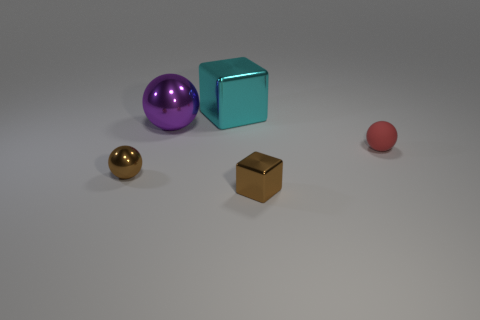Add 1 tiny brown metallic things. How many objects exist? 6 Subtract all red matte spheres. How many spheres are left? 2 Subtract all spheres. How many objects are left? 2 Add 3 small cylinders. How many small cylinders exist? 3 Subtract all brown balls. How many balls are left? 2 Subtract 0 cyan cylinders. How many objects are left? 5 Subtract 2 cubes. How many cubes are left? 0 Subtract all brown cubes. Subtract all blue spheres. How many cubes are left? 1 Subtract all red spheres. Subtract all big blue shiny blocks. How many objects are left? 4 Add 4 small rubber objects. How many small rubber objects are left? 5 